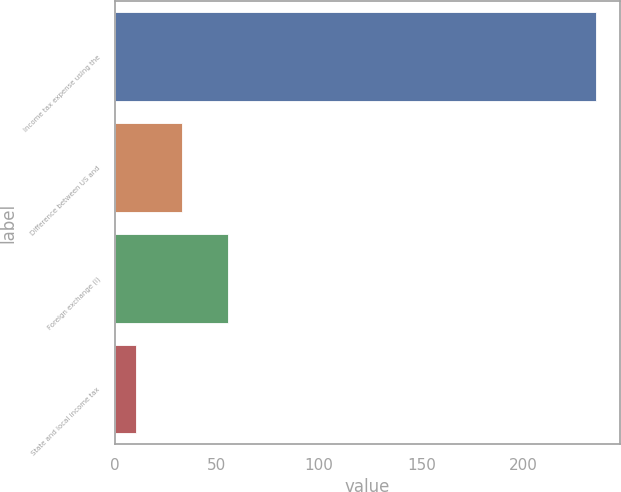Convert chart to OTSL. <chart><loc_0><loc_0><loc_500><loc_500><bar_chart><fcel>Income tax expense using the<fcel>Difference between US and<fcel>Foreign exchange (i)<fcel>State and local income tax<nl><fcel>235.4<fcel>32.81<fcel>55.32<fcel>10.3<nl></chart> 